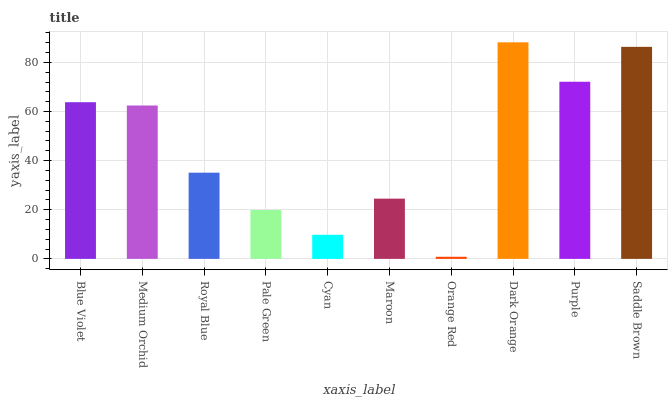Is Orange Red the minimum?
Answer yes or no. Yes. Is Dark Orange the maximum?
Answer yes or no. Yes. Is Medium Orchid the minimum?
Answer yes or no. No. Is Medium Orchid the maximum?
Answer yes or no. No. Is Blue Violet greater than Medium Orchid?
Answer yes or no. Yes. Is Medium Orchid less than Blue Violet?
Answer yes or no. Yes. Is Medium Orchid greater than Blue Violet?
Answer yes or no. No. Is Blue Violet less than Medium Orchid?
Answer yes or no. No. Is Medium Orchid the high median?
Answer yes or no. Yes. Is Royal Blue the low median?
Answer yes or no. Yes. Is Purple the high median?
Answer yes or no. No. Is Orange Red the low median?
Answer yes or no. No. 